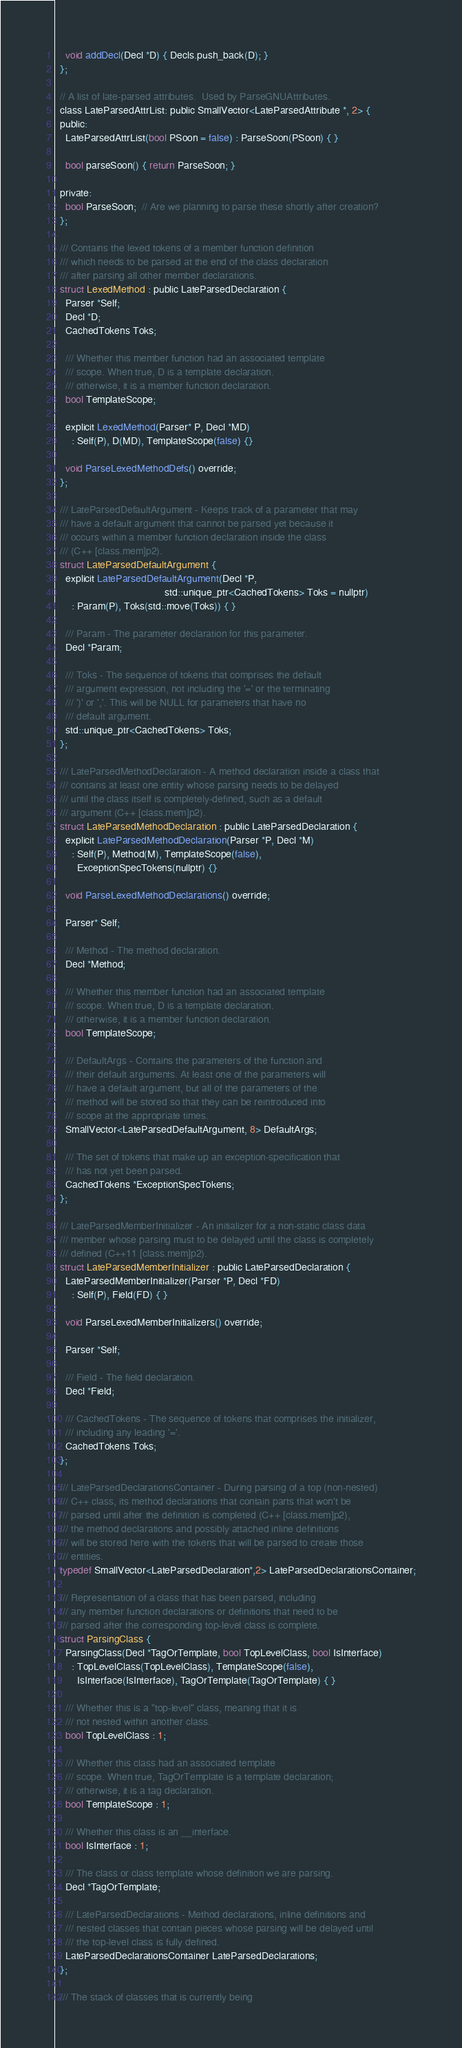<code> <loc_0><loc_0><loc_500><loc_500><_C_>    void addDecl(Decl *D) { Decls.push_back(D); }
  };

  // A list of late-parsed attributes.  Used by ParseGNUAttributes.
  class LateParsedAttrList: public SmallVector<LateParsedAttribute *, 2> {
  public:
    LateParsedAttrList(bool PSoon = false) : ParseSoon(PSoon) { }

    bool parseSoon() { return ParseSoon; }

  private:
    bool ParseSoon;  // Are we planning to parse these shortly after creation?
  };

  /// Contains the lexed tokens of a member function definition
  /// which needs to be parsed at the end of the class declaration
  /// after parsing all other member declarations.
  struct LexedMethod : public LateParsedDeclaration {
    Parser *Self;
    Decl *D;
    CachedTokens Toks;

    /// Whether this member function had an associated template
    /// scope. When true, D is a template declaration.
    /// otherwise, it is a member function declaration.
    bool TemplateScope;

    explicit LexedMethod(Parser* P, Decl *MD)
      : Self(P), D(MD), TemplateScope(false) {}

    void ParseLexedMethodDefs() override;
  };

  /// LateParsedDefaultArgument - Keeps track of a parameter that may
  /// have a default argument that cannot be parsed yet because it
  /// occurs within a member function declaration inside the class
  /// (C++ [class.mem]p2).
  struct LateParsedDefaultArgument {
    explicit LateParsedDefaultArgument(Decl *P,
                                       std::unique_ptr<CachedTokens> Toks = nullptr)
      : Param(P), Toks(std::move(Toks)) { }

    /// Param - The parameter declaration for this parameter.
    Decl *Param;

    /// Toks - The sequence of tokens that comprises the default
    /// argument expression, not including the '=' or the terminating
    /// ')' or ','. This will be NULL for parameters that have no
    /// default argument.
    std::unique_ptr<CachedTokens> Toks;
  };

  /// LateParsedMethodDeclaration - A method declaration inside a class that
  /// contains at least one entity whose parsing needs to be delayed
  /// until the class itself is completely-defined, such as a default
  /// argument (C++ [class.mem]p2).
  struct LateParsedMethodDeclaration : public LateParsedDeclaration {
    explicit LateParsedMethodDeclaration(Parser *P, Decl *M)
      : Self(P), Method(M), TemplateScope(false),
        ExceptionSpecTokens(nullptr) {}

    void ParseLexedMethodDeclarations() override;

    Parser* Self;

    /// Method - The method declaration.
    Decl *Method;

    /// Whether this member function had an associated template
    /// scope. When true, D is a template declaration.
    /// otherwise, it is a member function declaration.
    bool TemplateScope;

    /// DefaultArgs - Contains the parameters of the function and
    /// their default arguments. At least one of the parameters will
    /// have a default argument, but all of the parameters of the
    /// method will be stored so that they can be reintroduced into
    /// scope at the appropriate times.
    SmallVector<LateParsedDefaultArgument, 8> DefaultArgs;

    /// The set of tokens that make up an exception-specification that
    /// has not yet been parsed.
    CachedTokens *ExceptionSpecTokens;
  };

  /// LateParsedMemberInitializer - An initializer for a non-static class data
  /// member whose parsing must to be delayed until the class is completely
  /// defined (C++11 [class.mem]p2).
  struct LateParsedMemberInitializer : public LateParsedDeclaration {
    LateParsedMemberInitializer(Parser *P, Decl *FD)
      : Self(P), Field(FD) { }

    void ParseLexedMemberInitializers() override;

    Parser *Self;

    /// Field - The field declaration.
    Decl *Field;

    /// CachedTokens - The sequence of tokens that comprises the initializer,
    /// including any leading '='.
    CachedTokens Toks;
  };

  /// LateParsedDeclarationsContainer - During parsing of a top (non-nested)
  /// C++ class, its method declarations that contain parts that won't be
  /// parsed until after the definition is completed (C++ [class.mem]p2),
  /// the method declarations and possibly attached inline definitions
  /// will be stored here with the tokens that will be parsed to create those
  /// entities.
  typedef SmallVector<LateParsedDeclaration*,2> LateParsedDeclarationsContainer;

  /// Representation of a class that has been parsed, including
  /// any member function declarations or definitions that need to be
  /// parsed after the corresponding top-level class is complete.
  struct ParsingClass {
    ParsingClass(Decl *TagOrTemplate, bool TopLevelClass, bool IsInterface)
      : TopLevelClass(TopLevelClass), TemplateScope(false),
        IsInterface(IsInterface), TagOrTemplate(TagOrTemplate) { }

    /// Whether this is a "top-level" class, meaning that it is
    /// not nested within another class.
    bool TopLevelClass : 1;

    /// Whether this class had an associated template
    /// scope. When true, TagOrTemplate is a template declaration;
    /// otherwise, it is a tag declaration.
    bool TemplateScope : 1;

    /// Whether this class is an __interface.
    bool IsInterface : 1;

    /// The class or class template whose definition we are parsing.
    Decl *TagOrTemplate;

    /// LateParsedDeclarations - Method declarations, inline definitions and
    /// nested classes that contain pieces whose parsing will be delayed until
    /// the top-level class is fully defined.
    LateParsedDeclarationsContainer LateParsedDeclarations;
  };

  /// The stack of classes that is currently being</code> 